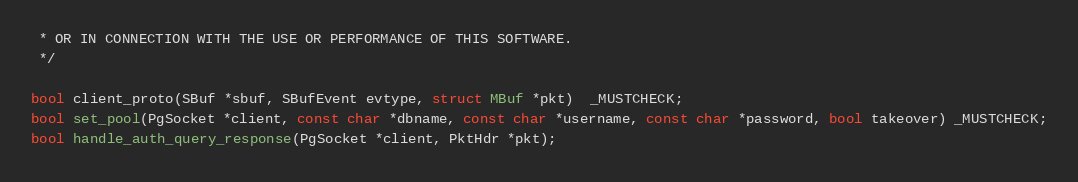<code> <loc_0><loc_0><loc_500><loc_500><_C_> * OR IN CONNECTION WITH THE USE OR PERFORMANCE OF THIS SOFTWARE.
 */

bool client_proto(SBuf *sbuf, SBufEvent evtype, struct MBuf *pkt)  _MUSTCHECK;
bool set_pool(PgSocket *client, const char *dbname, const char *username, const char *password, bool takeover) _MUSTCHECK;
bool handle_auth_query_response(PgSocket *client, PktHdr *pkt);
</code> 